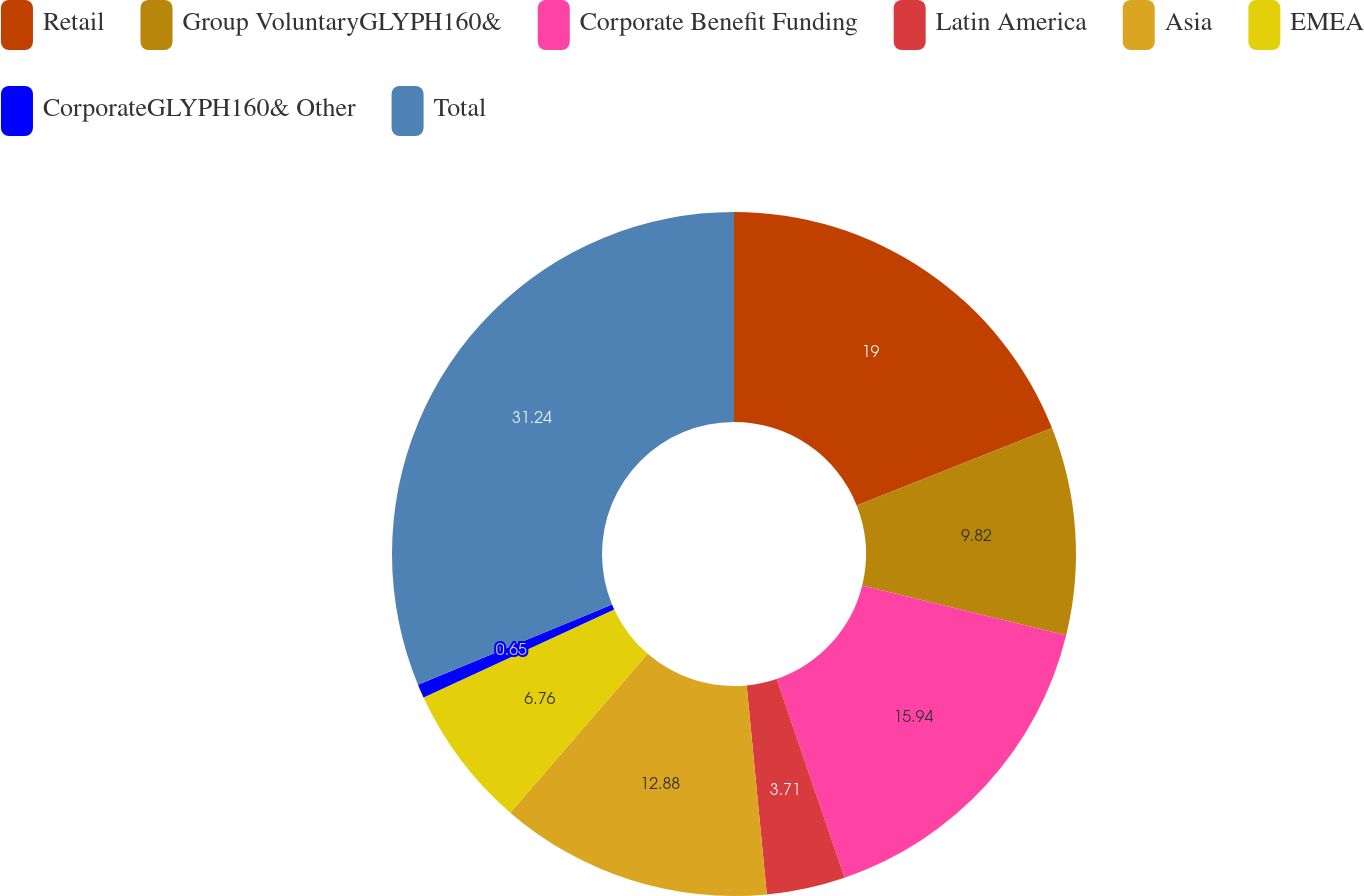<chart> <loc_0><loc_0><loc_500><loc_500><pie_chart><fcel>Retail<fcel>Group VoluntaryGLYPH160&<fcel>Corporate Benefit Funding<fcel>Latin America<fcel>Asia<fcel>EMEA<fcel>CorporateGLYPH160& Other<fcel>Total<nl><fcel>19.0%<fcel>9.82%<fcel>15.94%<fcel>3.71%<fcel>12.88%<fcel>6.76%<fcel>0.65%<fcel>31.24%<nl></chart> 